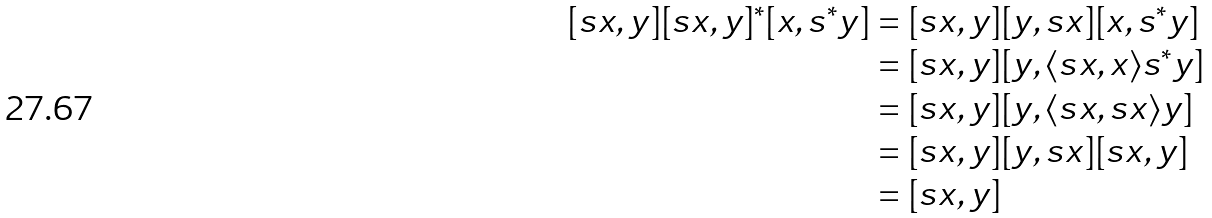Convert formula to latex. <formula><loc_0><loc_0><loc_500><loc_500>[ s x , y ] [ s x , y ] ^ { * } [ x , s ^ { * } y ] & = [ s x , y ] [ y , s x ] [ x , s ^ { * } y ] \\ & = [ s x , y ] [ y , \langle s x , x \rangle s ^ { * } y ] \\ & = [ s x , y ] [ y , \langle s x , s x \rangle y ] \\ & = [ s x , y ] [ y , s x ] [ s x , y ] \\ & = [ s x , y ]</formula> 